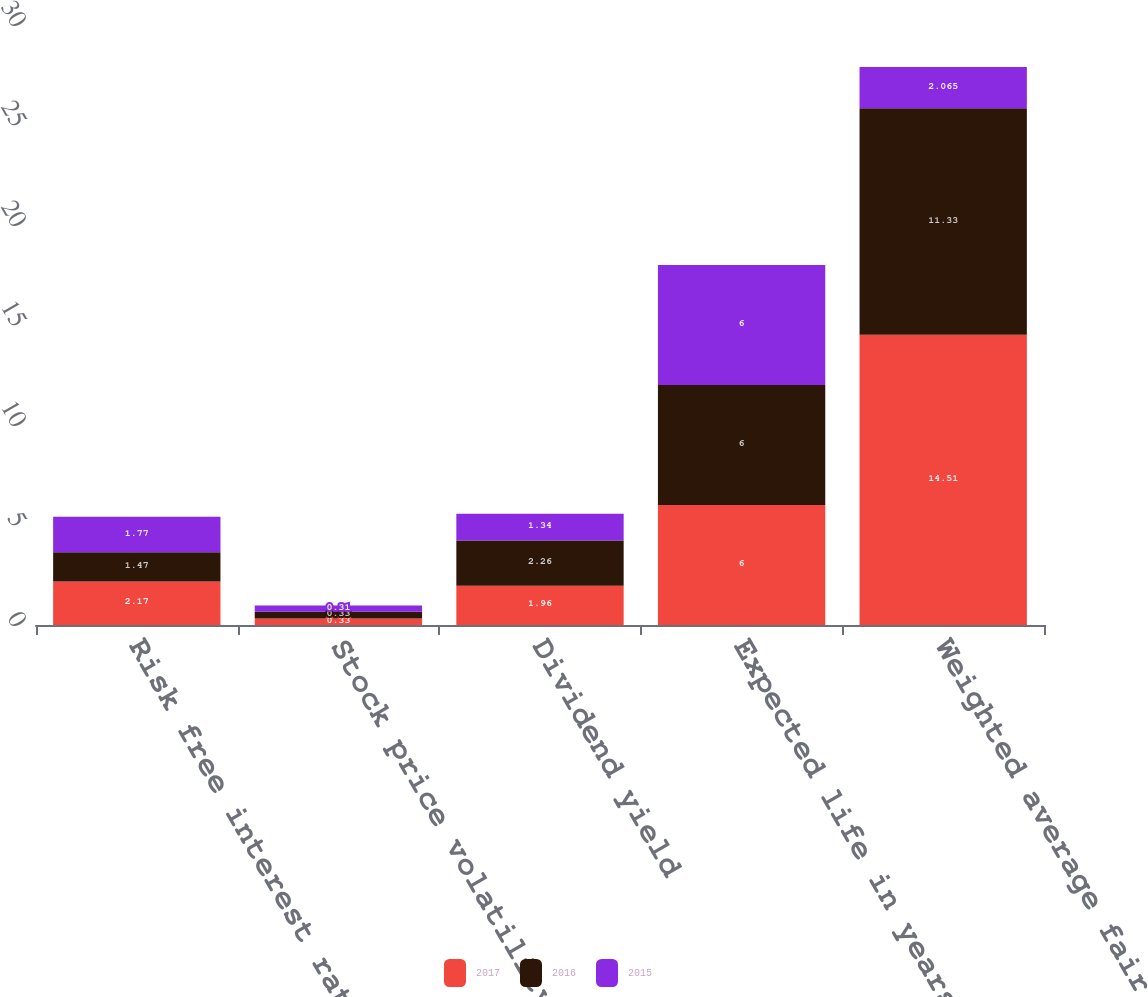<chart> <loc_0><loc_0><loc_500><loc_500><stacked_bar_chart><ecel><fcel>Risk free interest rate<fcel>Stock price volatility<fcel>Dividend yield<fcel>Expected life in years<fcel>Weighted average fair value<nl><fcel>2017<fcel>2.17<fcel>0.33<fcel>1.96<fcel>6<fcel>14.51<nl><fcel>2016<fcel>1.47<fcel>0.33<fcel>2.26<fcel>6<fcel>11.33<nl><fcel>2015<fcel>1.77<fcel>0.31<fcel>1.34<fcel>6<fcel>2.065<nl></chart> 